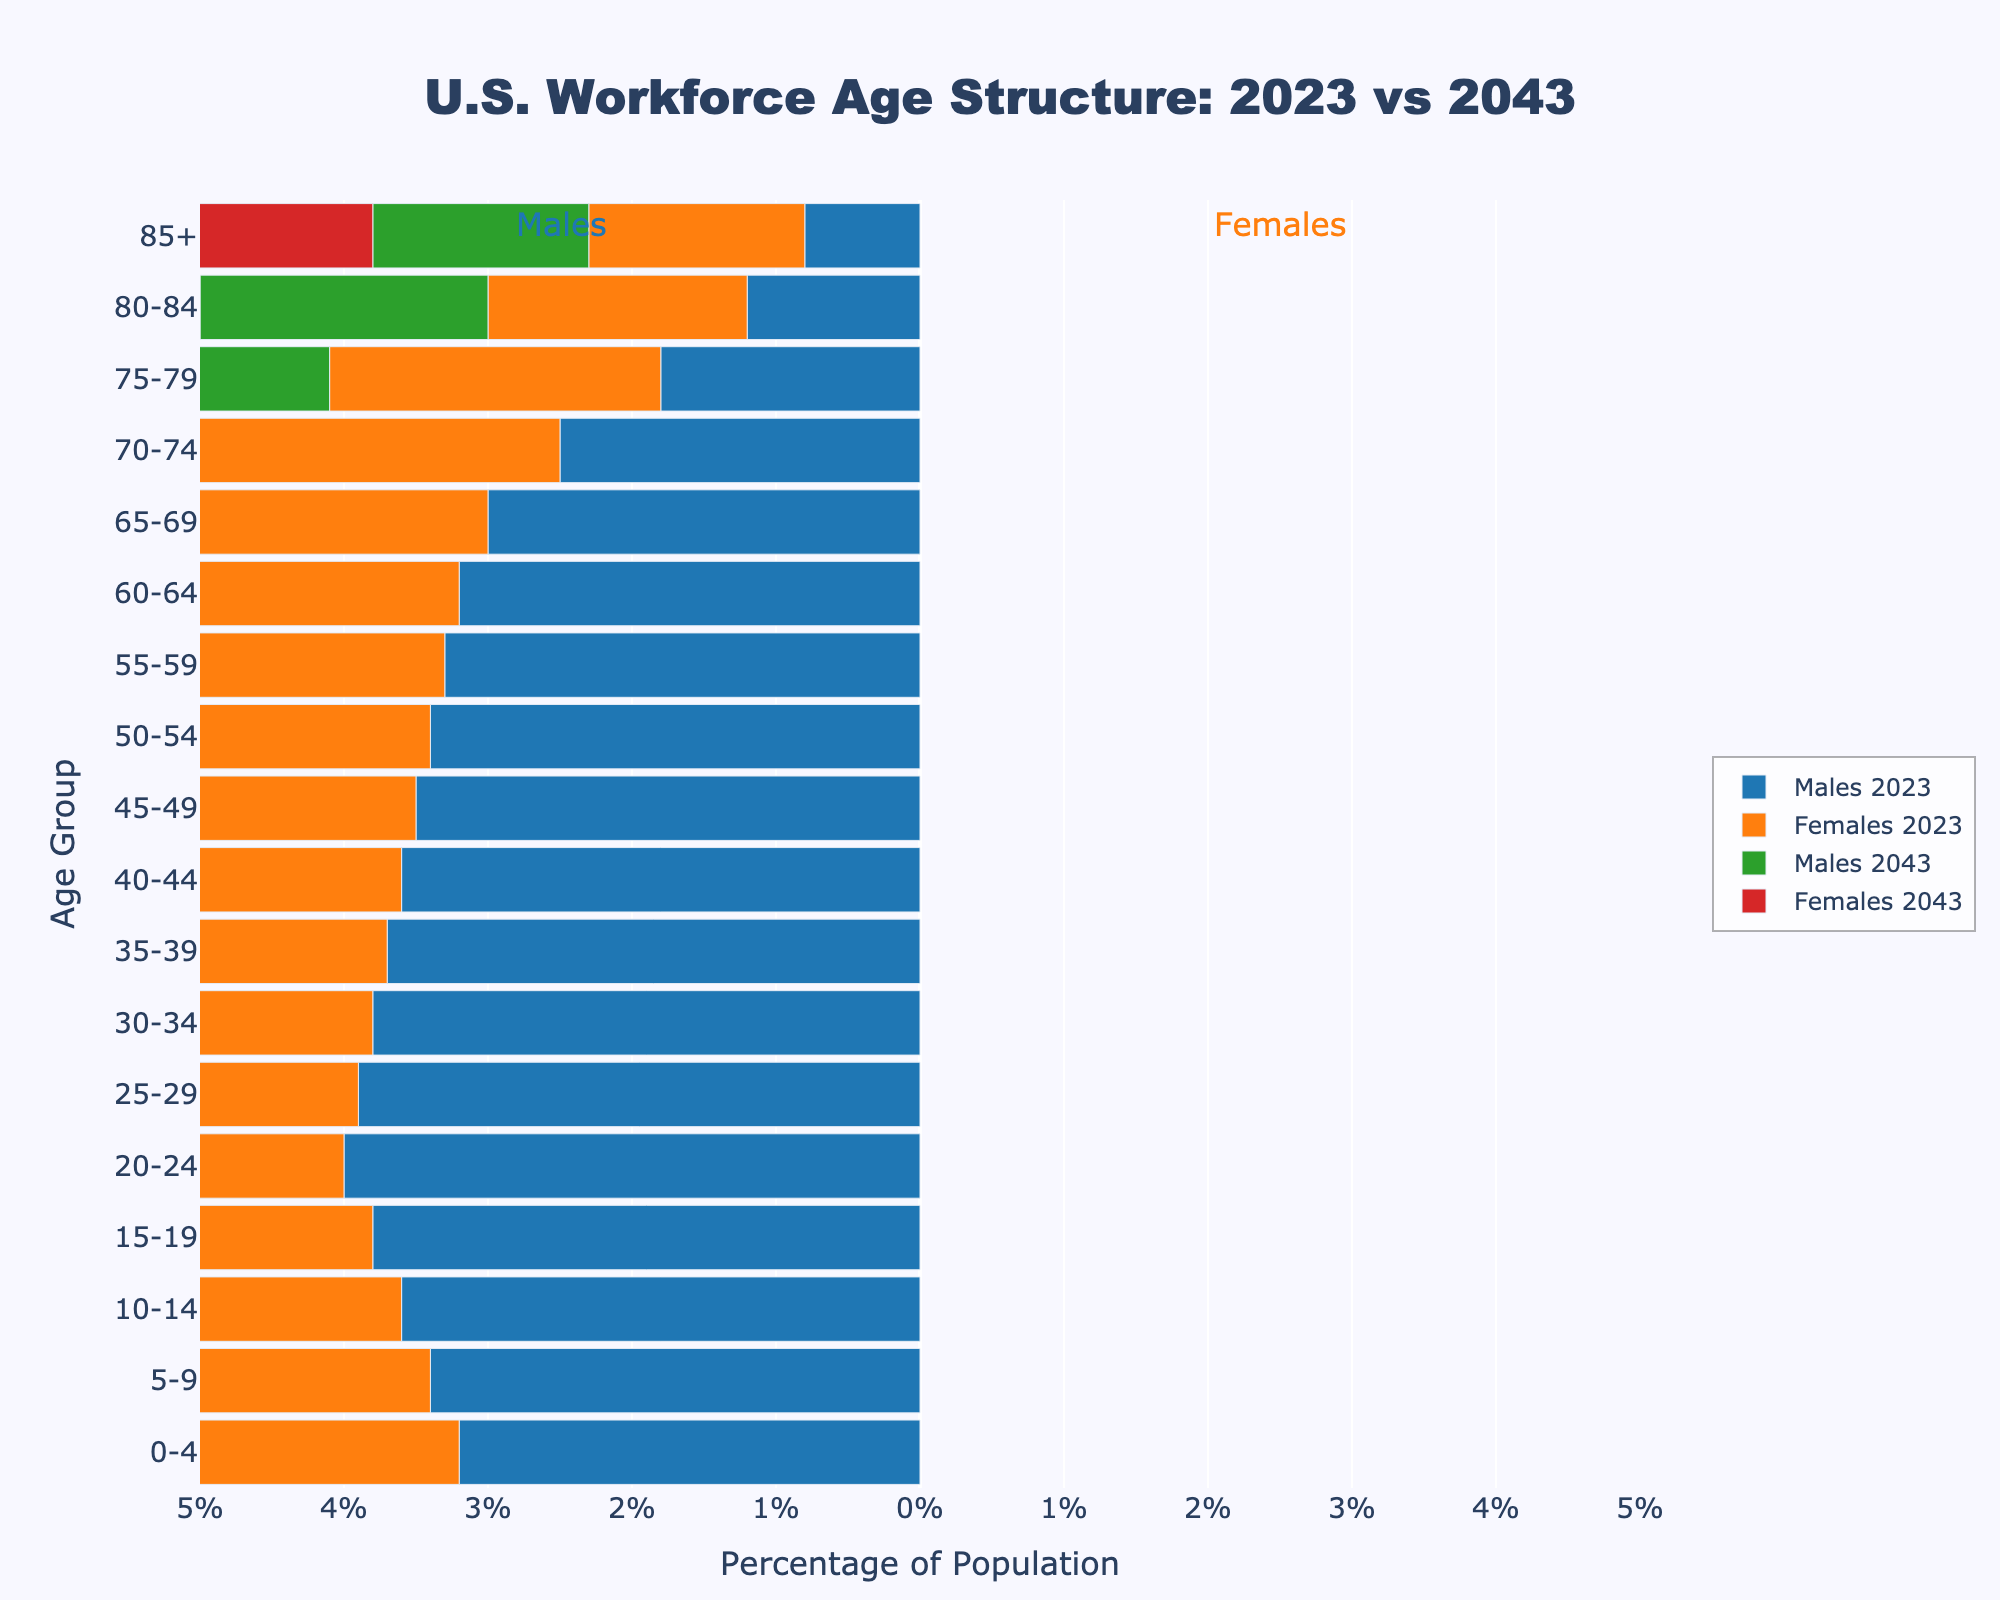What is the title of the figure? The title is usually found at the top of the figure, and it provides a brief description of what the figure represents. In this case, the title is "U.S. Workforce Age Structure: 2023 vs 2043".
Answer: U.S. Workforce Age Structure: 2023 vs 2043 Which age group has the highest percentage in the workforce in both 2023 and 2043 for males? To determine this, we need to find the age group with the highest value in the "Males 2023" and "Males 2043" categories. According to the data, the age group with the highest percentage in both years is "20-24". In 2023, the value is -4.0%, and in 2043, it is -4.1%.
Answer: 20-24 How does the percentage of females aged 85+ change from 2023 to 2043? To find the change, subtract the percentage for 2023 from the percentage for 2043. For females aged 85+, the percentage in 2023 is -1.5%, and in 2043 it is -2.3%. The change is -2.3% - (-1.5%) = -0.8%.
Answer: -0.8% In which year is the percentage of males aged 50-54 higher, and by how much? We compare the values for "Males 2023" and "Males 2043" for the age group 50-54. In 2023, the value is -3.4%, and in 2043 it is -3.5%. The difference is -3.4% - (-3.5%) = 0.1%. Males aged 50-54 have a higher percentage in 2023 by 0.1%.
Answer: 2023, 0.1% What is the overall trend in the age structure of the U.S. workforce from 2023 to 2043? By analyzing the data, we can observe that in 2043, all age groups have higher negative values compared to 2023, indicating an overall aging of the workforce. This trend reflects an increasing older population in the workforce over the next two decades.
Answer: Aging workforce Between which years will the age group 70-74 see the most significant increase in percentage for females? To find this, compare the values for "Females 2023" and "Females 2043" for the age group 70-74. The percentage in 2023 is -2.9%, and in 2043 it is -3.3%. The increase is -3.3% - (-2.9%) = -0.4%, indicating the most significant increase.
Answer: 2023-2043 Which age group and gender show the smallest change in percentage from 2023 to 2043? We need to find the smallest change by comparing the difference in values between 2023 and 2043. For males, the smallest change is in the age group 65-69, with a difference of -3.0% to -3.2% (0.2%). For females, the smallest change is in the age group 0-4, with a difference of -3.5% to -3.6% (0.1%). Therefore, the smallest change overall is among females aged 0-4.
Answer: Females 0-4 Which gender and age group will see its highest increase in population percentage by 2043? To determine this, compare the increases for each gender and age group from 2023 to 2043. The highest increase is for males aged 85+, which changes from -0.8% in 2023 to -1.5% in 2043. The increase is -1.5% - (-0.8%) = -0.7%.
Answer: Males 85+ What percentage of the workforce aged 60-64 is female in 2043? To find this, we look at the data for "Females 2043" in the age group 60-64. The percentage is -3.6%.
Answer: -3.6% How much will the percentage of males aged 75-79 decrease from 2023 to 2043? The percentage of males aged 75-79 in 2023 is -1.8%, and in 2043 it is -2.5%. The decrease is found by subtracting the 2043 value from the 2023 value: -2.5% - (-1.8%) = -0.7%.
Answer: -0.7% 